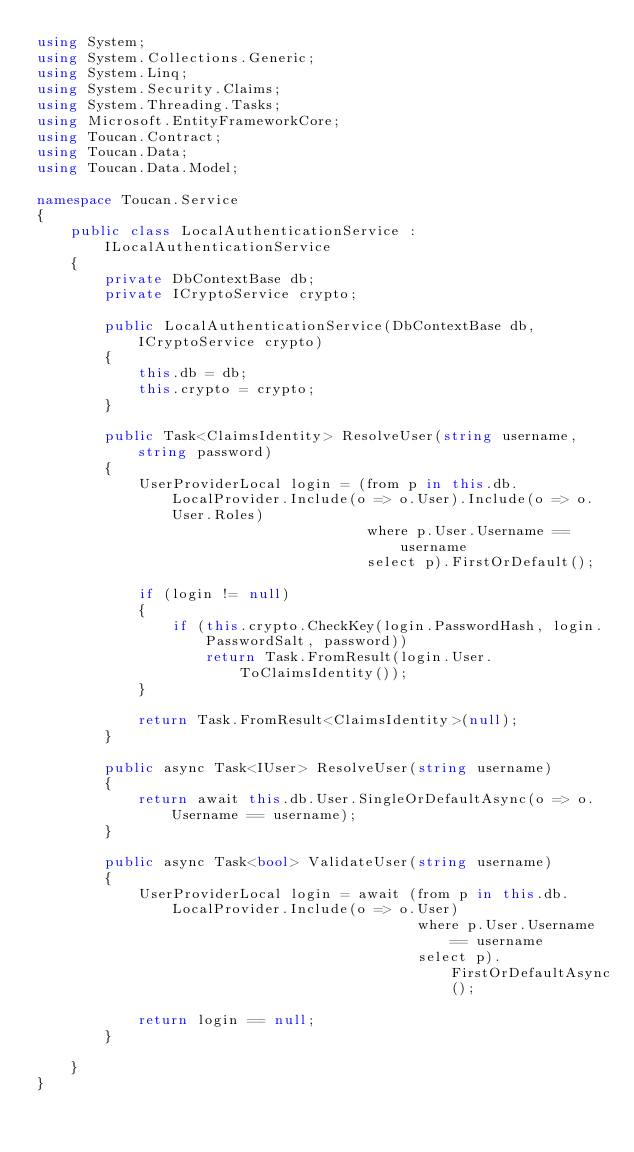Convert code to text. <code><loc_0><loc_0><loc_500><loc_500><_C#_>using System;
using System.Collections.Generic;
using System.Linq;
using System.Security.Claims;
using System.Threading.Tasks;
using Microsoft.EntityFrameworkCore;
using Toucan.Contract;
using Toucan.Data;
using Toucan.Data.Model;

namespace Toucan.Service
{
    public class LocalAuthenticationService : ILocalAuthenticationService
    {
        private DbContextBase db;
        private ICryptoService crypto;

        public LocalAuthenticationService(DbContextBase db, ICryptoService crypto)
        {
            this.db = db;
            this.crypto = crypto;
        }

        public Task<ClaimsIdentity> ResolveUser(string username, string password)
        {
            UserProviderLocal login = (from p in this.db.LocalProvider.Include(o => o.User).Include(o => o.User.Roles)
                                       where p.User.Username == username
                                       select p).FirstOrDefault();

            if (login != null)
            {
                if (this.crypto.CheckKey(login.PasswordHash, login.PasswordSalt, password))
                    return Task.FromResult(login.User.ToClaimsIdentity());
            }

            return Task.FromResult<ClaimsIdentity>(null);
        }

        public async Task<IUser> ResolveUser(string username)
        {
            return await this.db.User.SingleOrDefaultAsync(o => o.Username == username);
        }

        public async Task<bool> ValidateUser(string username)
        {
            UserProviderLocal login = await (from p in this.db.LocalProvider.Include(o => o.User)
                                             where p.User.Username == username
                                             select p).FirstOrDefaultAsync();

            return login == null;
        }

    }
}
</code> 